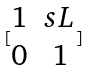<formula> <loc_0><loc_0><loc_500><loc_500>[ \begin{matrix} 1 & s L \\ 0 & 1 \end{matrix} ]</formula> 